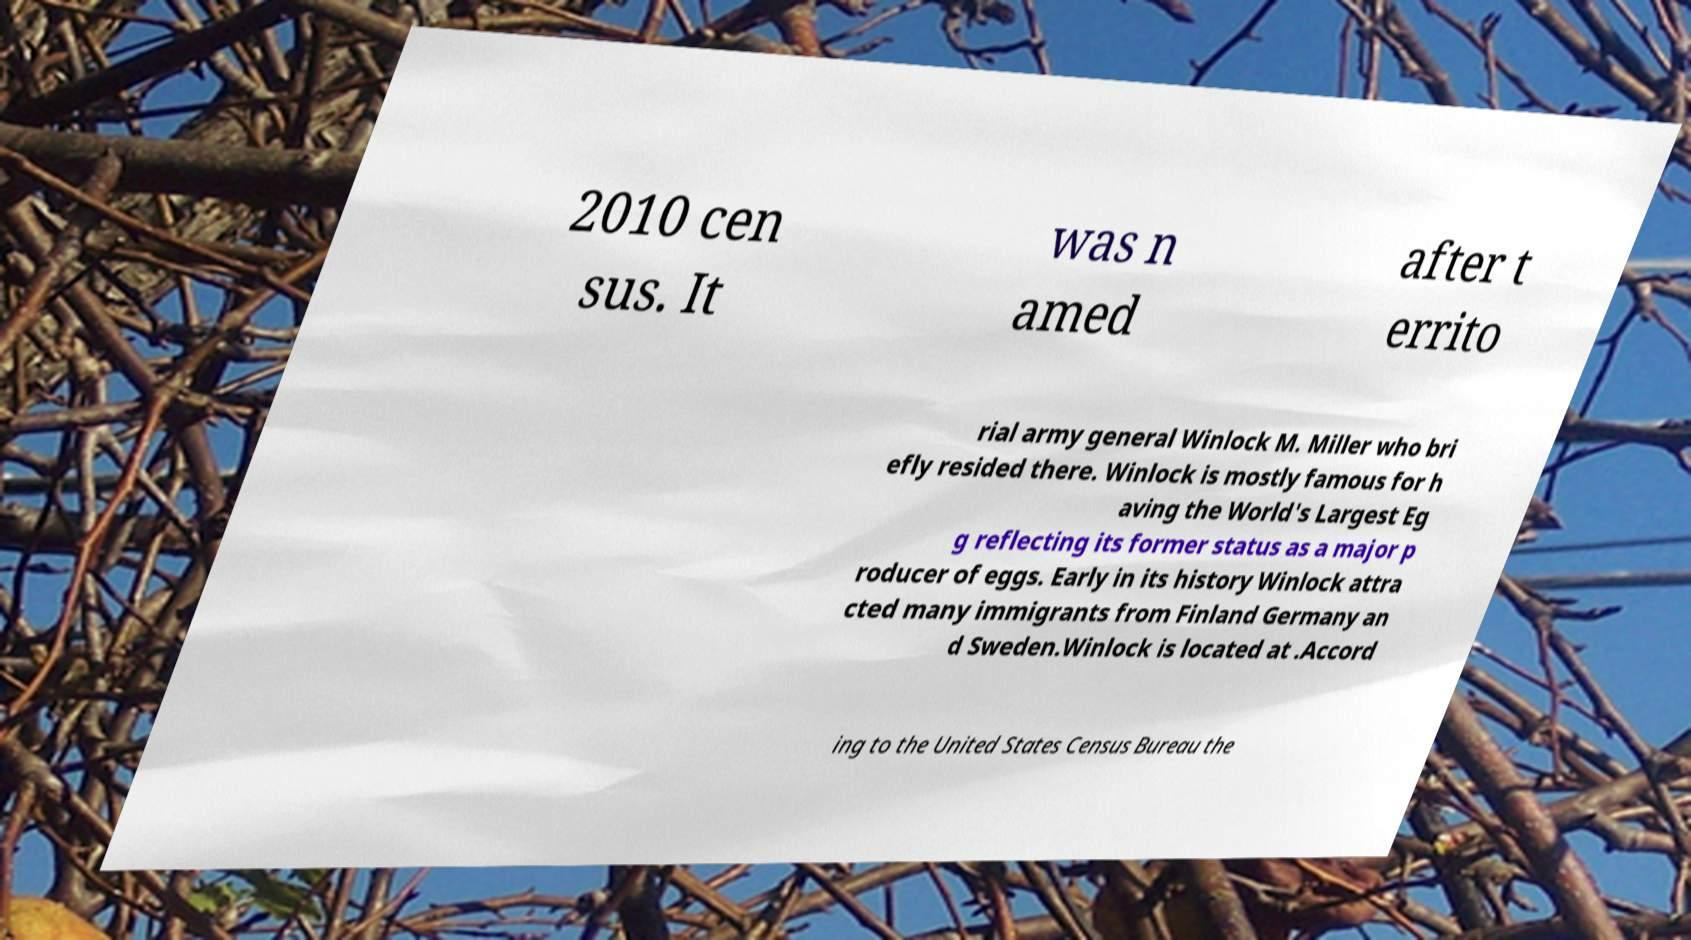Could you assist in decoding the text presented in this image and type it out clearly? 2010 cen sus. It was n amed after t errito rial army general Winlock M. Miller who bri efly resided there. Winlock is mostly famous for h aving the World's Largest Eg g reflecting its former status as a major p roducer of eggs. Early in its history Winlock attra cted many immigrants from Finland Germany an d Sweden.Winlock is located at .Accord ing to the United States Census Bureau the 